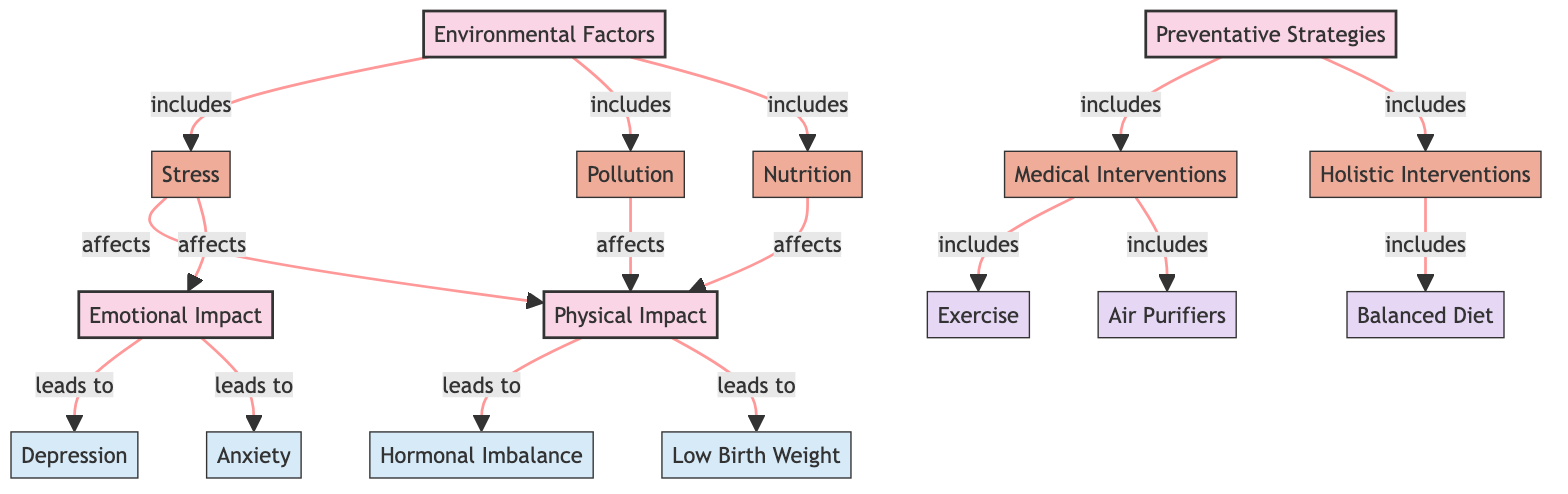What are the main environmental factors listed in the diagram? The diagram identifies three main environmental factors: Stress, Pollution, and Nutrition. These factors are categorized under the broader node "Environmental Factors."
Answer: Stress, Pollution, Nutrition How many impacts are identified under Physical and Emotional Impact? The diagram specifies four impacts in total, with two listed under Physical Impact (Hormonal Imbalance, Low Birth Weight) and two under Emotional Impact (Depression, Anxiety). Adding these gives a total of four impacts.
Answer: 4 Which preventative strategy is linked to Medical Interventions? Under the Preventative Strategies category, the Medical Interventions node includes two specific elements: Exercise and Air Purifiers, thus making that the answer.
Answer: Exercise, Air Purifiers How does Stress affect pregnancy according to the diagram? Stress is shown to affect both the Physical Impact and the Emotional Impact of pregnancy, demonstrating its dual role in influencing outcomes.
Answer: Affects Physical and Emotional Impact What is the relationship between Emotional Impact and Depression? The diagram illustrates that Emotional Impact leads directly to Depression, indicating that the emotional effects of environmental factors can significantly impact mental health during pregnancy.
Answer: Leads to Depression What are examples of Holistic Interventions listed in the diagram? Under the Holistic Interventions node, the diagram notes "Balanced Diet" as a specific example that emphasizes nutritional support as a holistic approach to pregnancy care.
Answer: Balanced Diet What are the two impacts listed under Physical Impact? The diagram provides two specific impacts related to Physical Impact, those being Hormonal Imbalance and Low Birth Weight. This highlights physical health concerns emerging from environmental factors.
Answer: Hormonal Imbalance, Low Birth Weight Which Environmental Factor has the strongest relation to both Physical and Emotional Impacts? Stress has a direct relationship with both Physical Impact and Emotional Impact as indicated in the diagram, suggesting its significant role in overall pregnancy health.
Answer: Stress How many nodes are categorized under Preventative Strategies? The diagram shows two nodes categorized under Preventative Strategies: Medical Interventions and Holistic Interventions. Thus, the total count of these nodes is two.
Answer: 2 